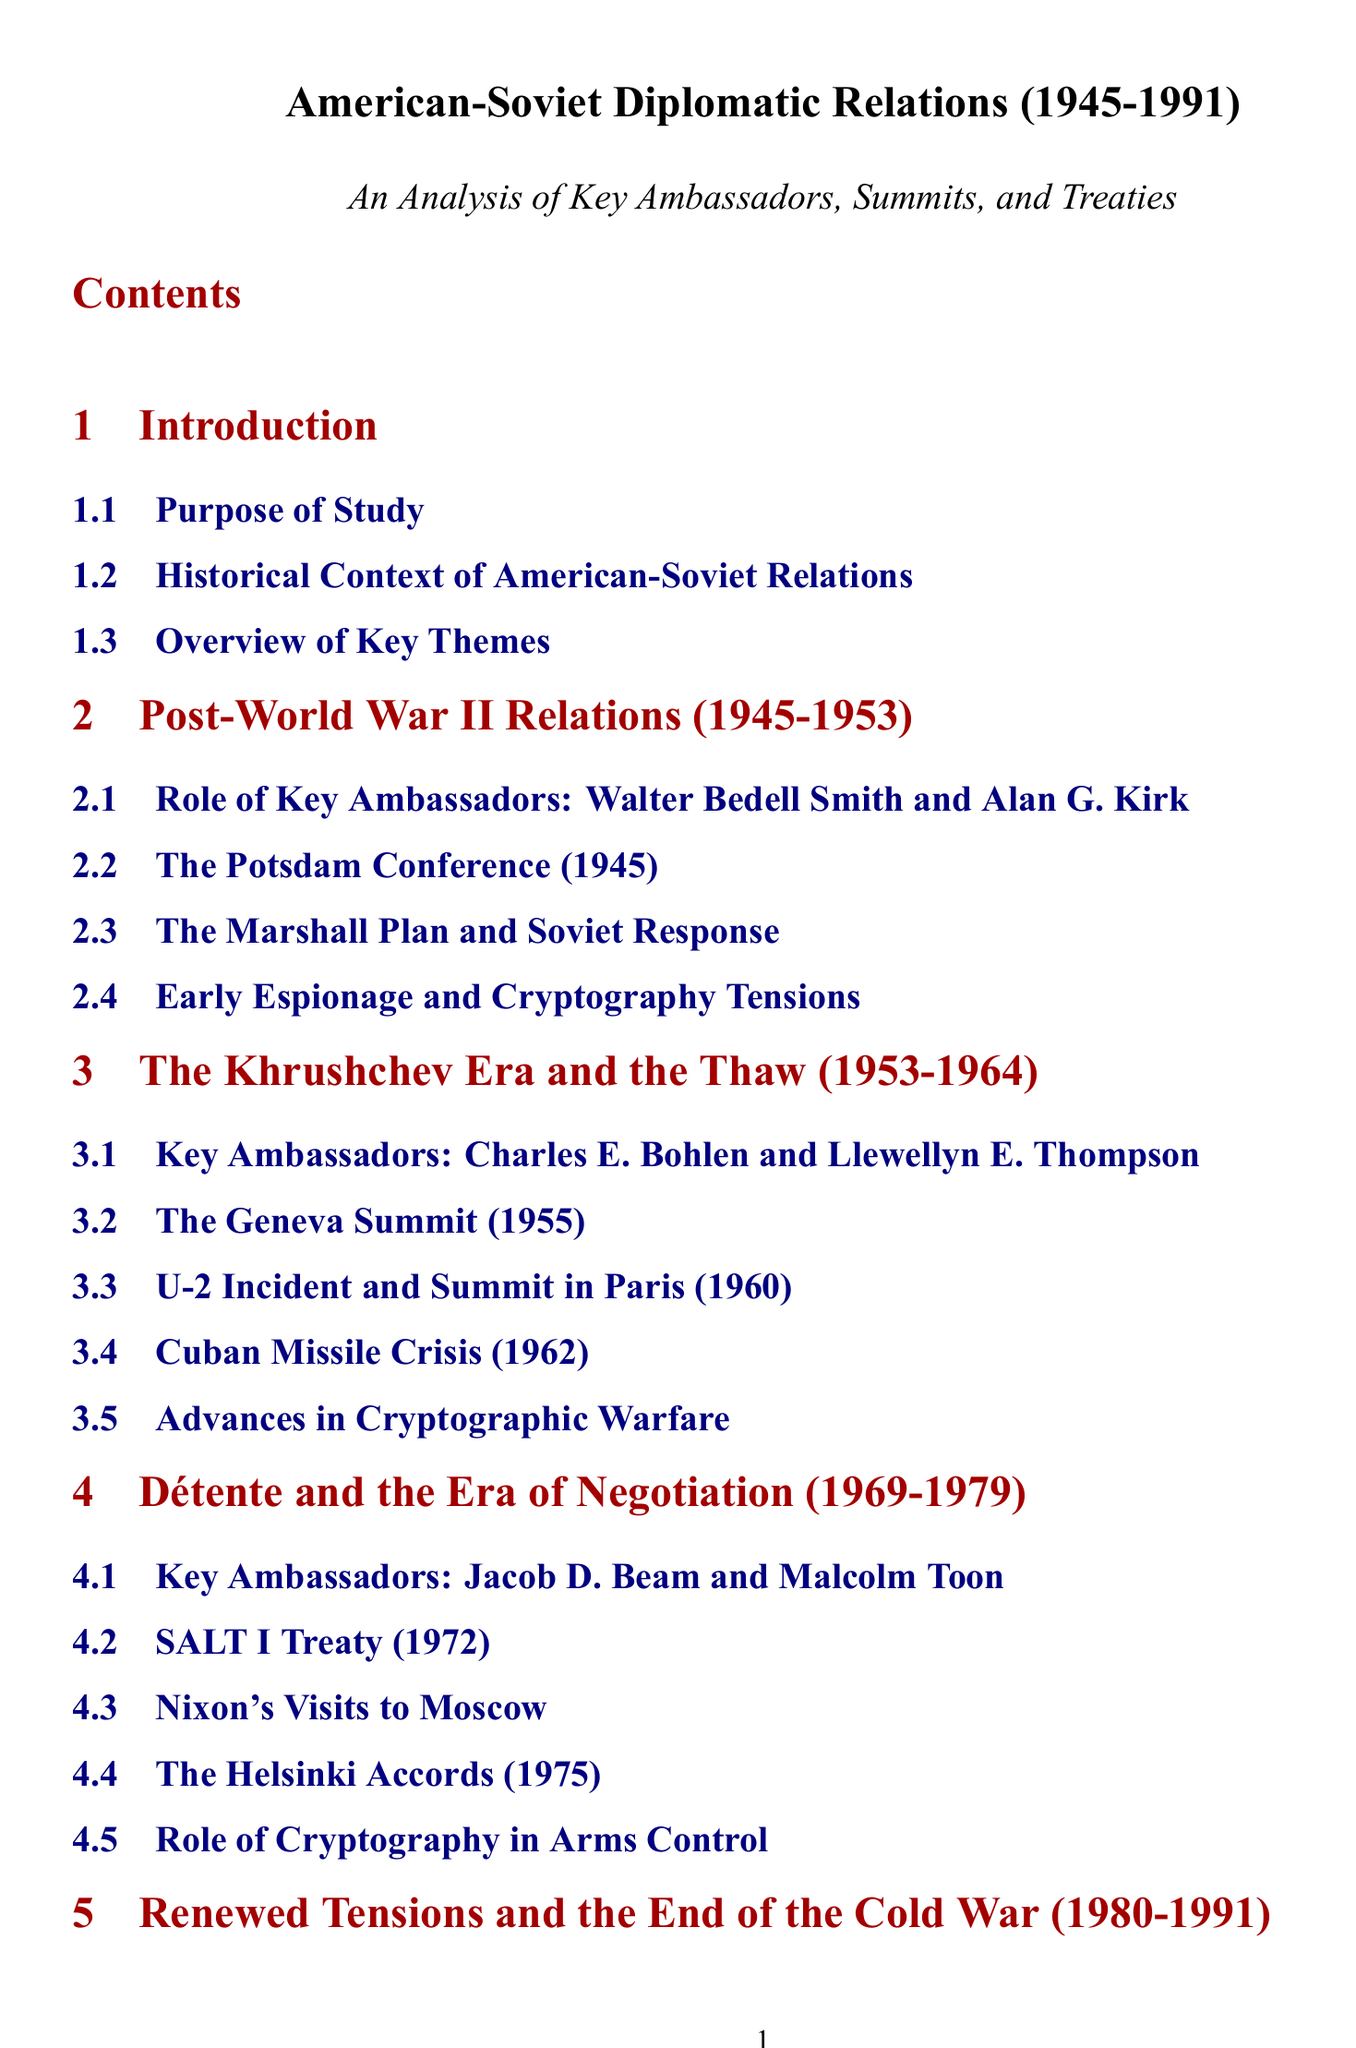What is the time period covered in this document? The document provides an overview of American-Soviet diplomatic relations from 1945 to 1991.
Answer: 1945 to 1991 Who were the key ambassadors during the Khrushchev Era? The section lists Charles E. Bohlen and Llewellyn E. Thompson as key ambassadors during this period.
Answer: Charles E. Bohlen and Llewellyn E. Thompson What significant event occurred in 1962? The document highlights the Cuban Missile Crisis as a major event in this year.
Answer: Cuban Missile Crisis Which treaty was signed in 1972? The SALT I Treaty is mentioned as a key treaty from this era.
Answer: SALT I Treaty What was the focus of the conclusion section? The conclusion summarizes key diplomatic developments and their impacts on relations.
Answer: Summary of Key Diplomatic Developments How many key ambassadors are listed for the post-World War II relations section? The section identifies two key ambassadors: Walter Bedell Smith and Alan G. Kirk.
Answer: Two What years are covered under Détente and the Era of Negotiation? This section covers the years 1969 to 1979.
Answer: 1969 to 1979 What was a notable summit in 1989? The Malta Summit is specifically mentioned as a significant event during this time frame.
Answer: Malta Summit How many sections are there in the document? The document consists of six main sections, including the introduction and conclusion.
Answer: Six 